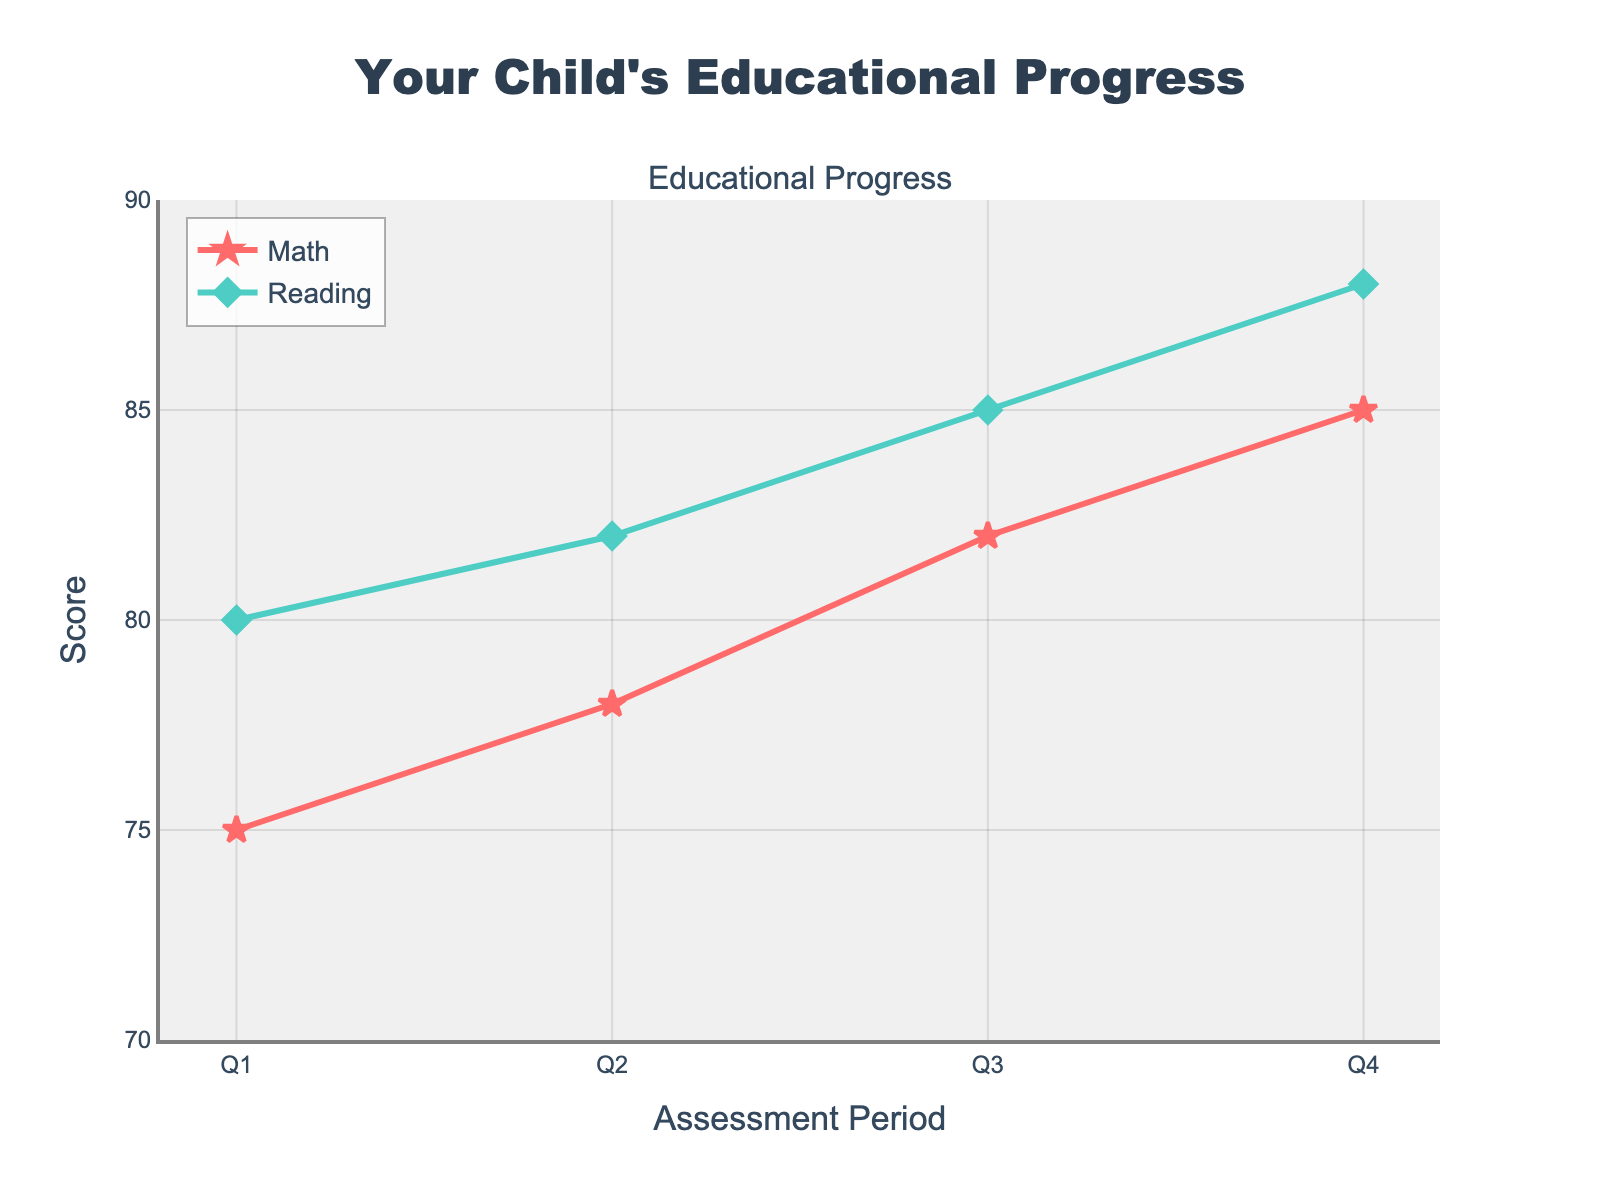What is the title of the chart? The title is displayed at the top center of the chart in bold letters. It reads "Your Child's Educational Progress".
Answer: Your Child's Educational Progress How many assessment periods are shown in the figure? Each point on the x-axis represents an assessment period. There are four periods labeled Q1 through Q4.
Answer: 4 What is the y-axis range for the scores? The y-axis display values between the minimum and maximum scores. The range is from 70 to 90.
Answer: 70 to 90 Which subject showed a greater increase in scores from Q1 to Q4? The Math scores went from 75 to 85, a 10-point increase. Reading scores went from 80 to 88, an 8-point increase.
Answer: Math What is the difference between the Math and Reading scores in Q3? According to the data points in Q3, the Math score is 82 and the Reading score is 85. The difference is 85 - 82.
Answer: 3 On average, how did the Math scores progress across the assessment periods? The Math scores are 75, 78, 82, and 85. Sum these scores and divide by the number of periods: (75 + 78 + 82 + 85) / 4.
Answer: 80 Did the Reading scores ever surpass 85? If so, during which assessment period? The Reading score reached 88 in Q4 which surpasses 85.
Answer: Q4 During which assessment period did both subjects show the closest scores? You need to check the difference in scores for each period. In Q1: 80-75 = 5, Q2: 82-78 = 4, Q3: 85-82 = 3, and Q4: 88-85 = 3. The smallest difference is in Q3 and Q4.
Answer: Q3, Q4 Could you identify an assessment period with the largest improvement for either subject, and what is that improvement? Compare the improvements between consecutive assessment periods. The biggest jump in Math scores is from Q2 to Q3 (4 points), and the highest jump in Reading scores is from Q3 to Q4 (3 points). Thus, Math from Q2 to Q3 is the largest improvement.
Answer: Q2 to Q3 Math, 4 points 